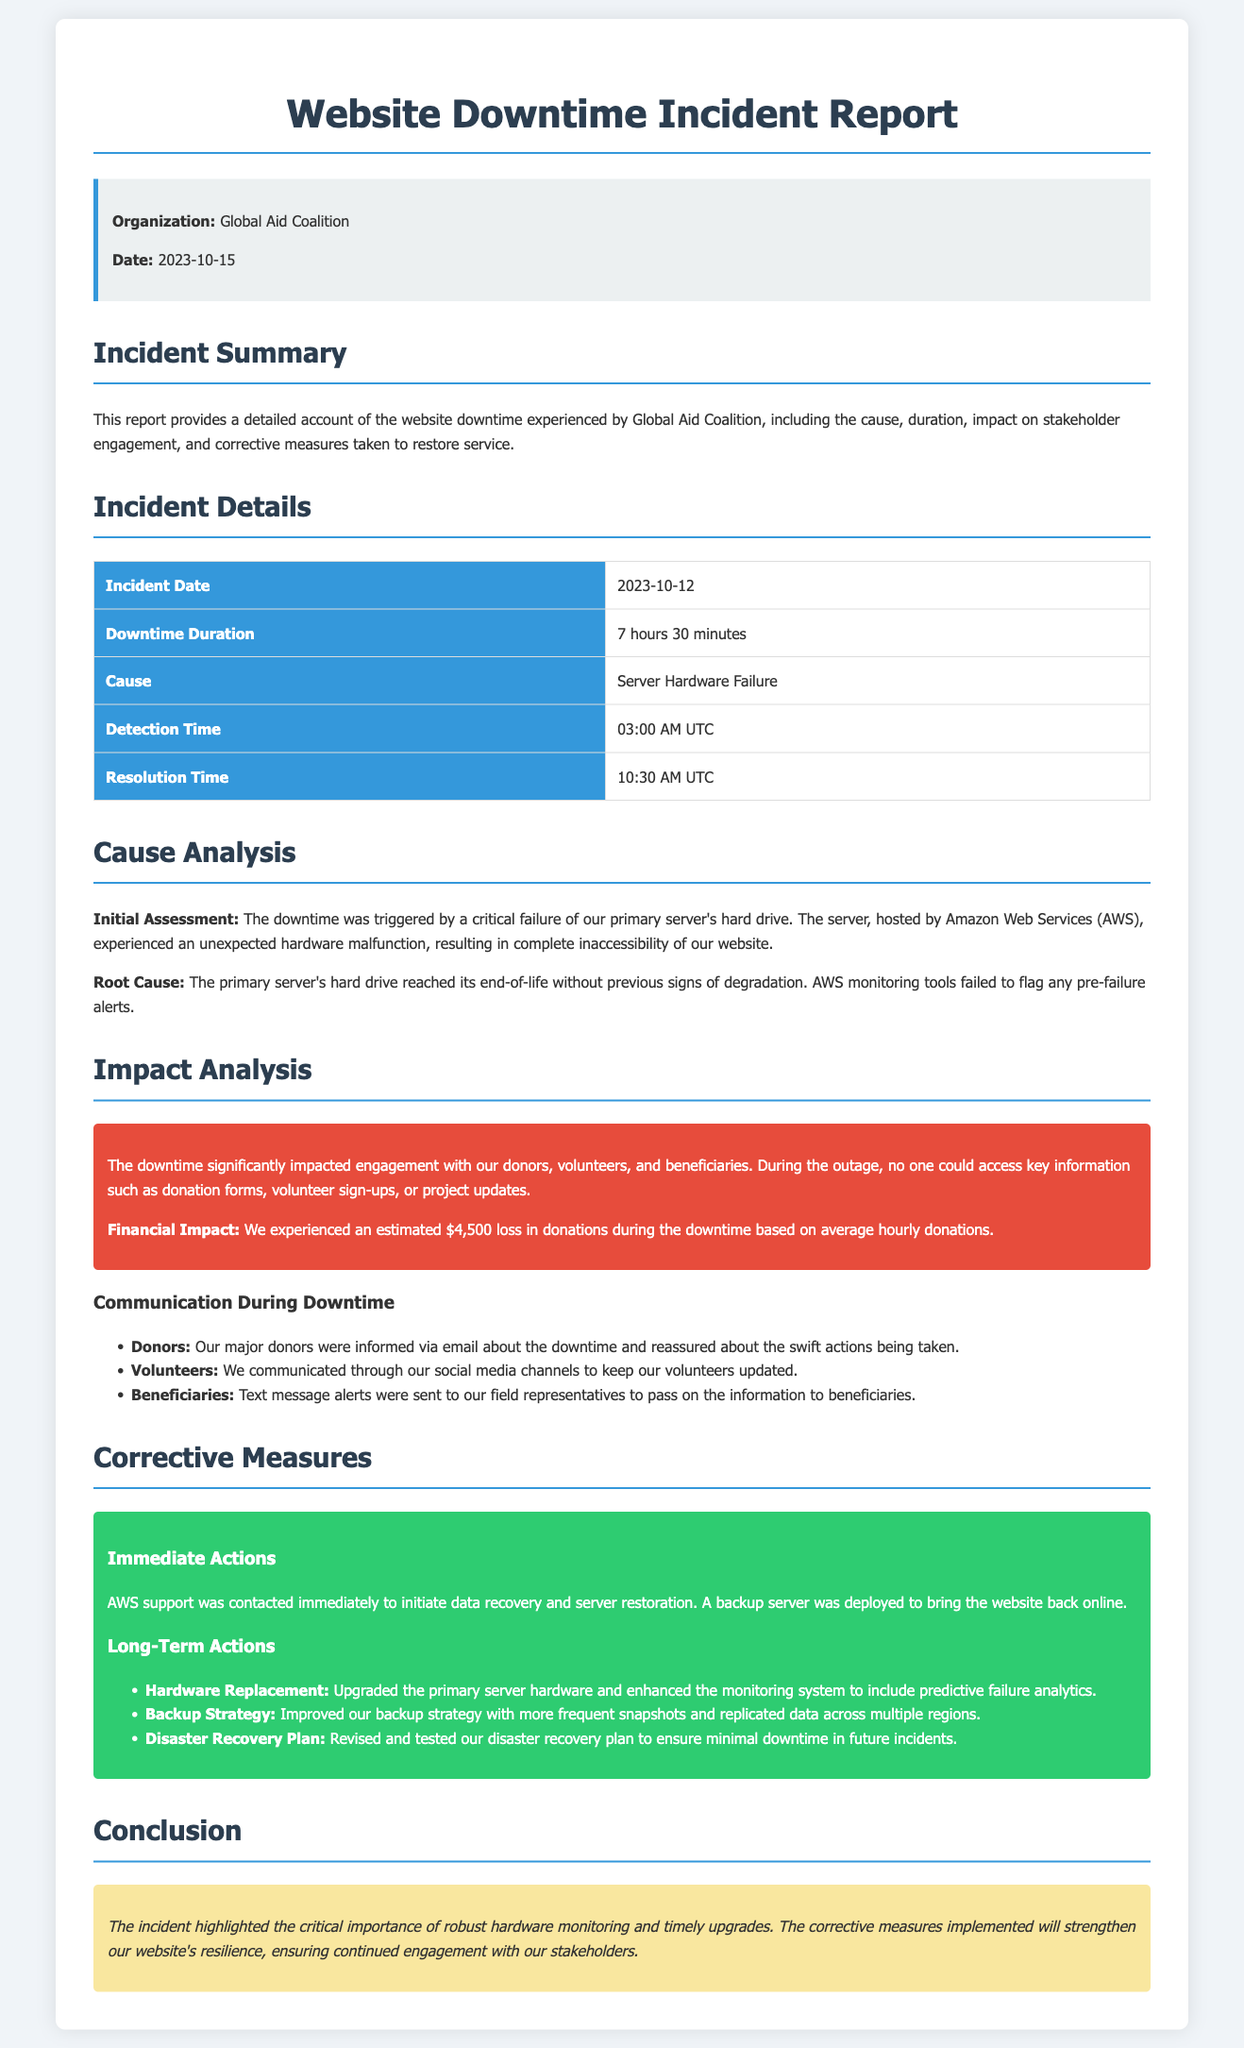What is the incident date? The incident date is specifically stated in the document as the date when the downtime occurred, which is 2023-10-12.
Answer: 2023-10-12 How long was the downtime? The downtime duration is given in the report as 7 hours 30 minutes, indicating the time the website was inaccessible.
Answer: 7 hours 30 minutes What caused the website downtime? The cause of the downtime is detailed in the document as a server hardware failure, which signifies the reason behind the incident.
Answer: Server Hardware Failure What was the estimated financial impact of the downtime? The financial impact is quantified in the document as an estimated loss of donations, specifically mentioned as $4,500.
Answer: $4,500 What time did the detection of the incident occur? The report states the detection time as 03:00 AM UTC, which specifies when the issue was first recognized.
Answer: 03:00 AM UTC What action was taken to restore the website? The document highlights that AWS support was contacted and a backup server was deployed, which explains the initial response to restore service.
Answer: Backup server was deployed How were the major donors informed during the downtime? The report specifies that major donors were informed via email, showing how the organization communicated during the incident.
Answer: Via email What corrective measures were taken long-term? The document outlines long-term actions such as upgrading hardware and improving the backup strategy, indicating measures planned to prevent future incidents.
Answer: Upgraded the primary server hardware What highlights the importance learned from the incident? The conclusion stresses the importance of robust hardware monitoring and timely upgrades as critical lessons learned from the incident.
Answer: Robust hardware monitoring 